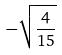Convert formula to latex. <formula><loc_0><loc_0><loc_500><loc_500>- \sqrt { \frac { 4 } { 1 5 } }</formula> 